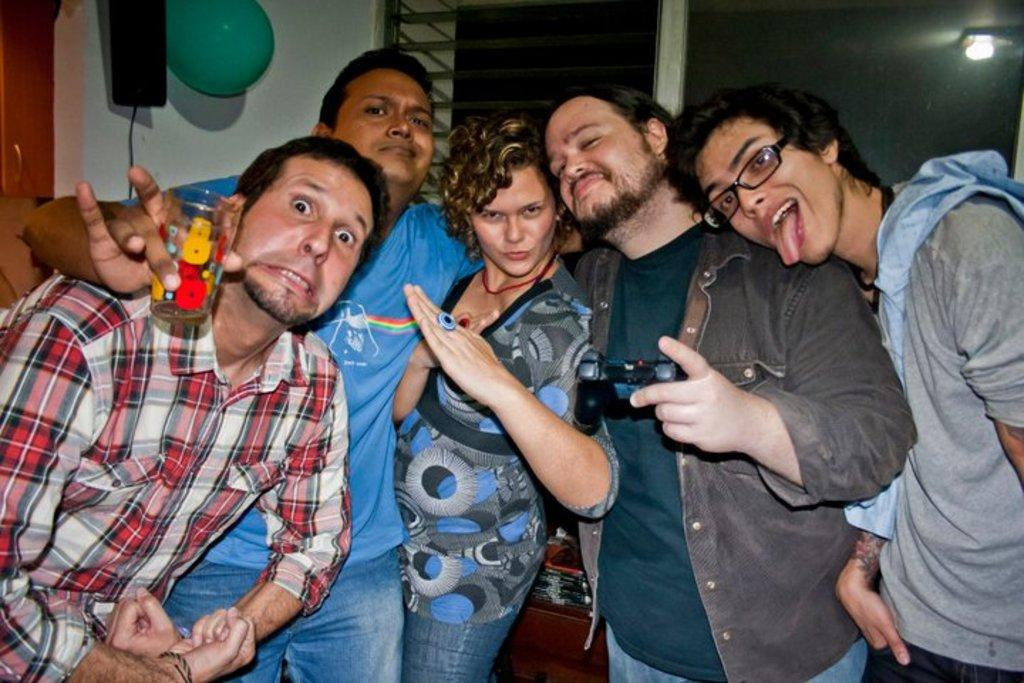How many people are present in the image? There are five persons standing in the image. What is one object visible in the image? There is a balloon in the image. Can you describe any other objects in the image? There are other objects in the image, but their specific details are not mentioned in the provided facts. What architectural feature can be seen in the image? There is a wall with a window in the image. Is there any lighting effect visible in the image? Yes, there is a reflection of light in the image. What type of rat can be seen interacting with the actor in the image? There is no rat or actor present in the image; the provided facts only mention five persons, a balloon, other objects, a wall with a window, and a reflection of light. 